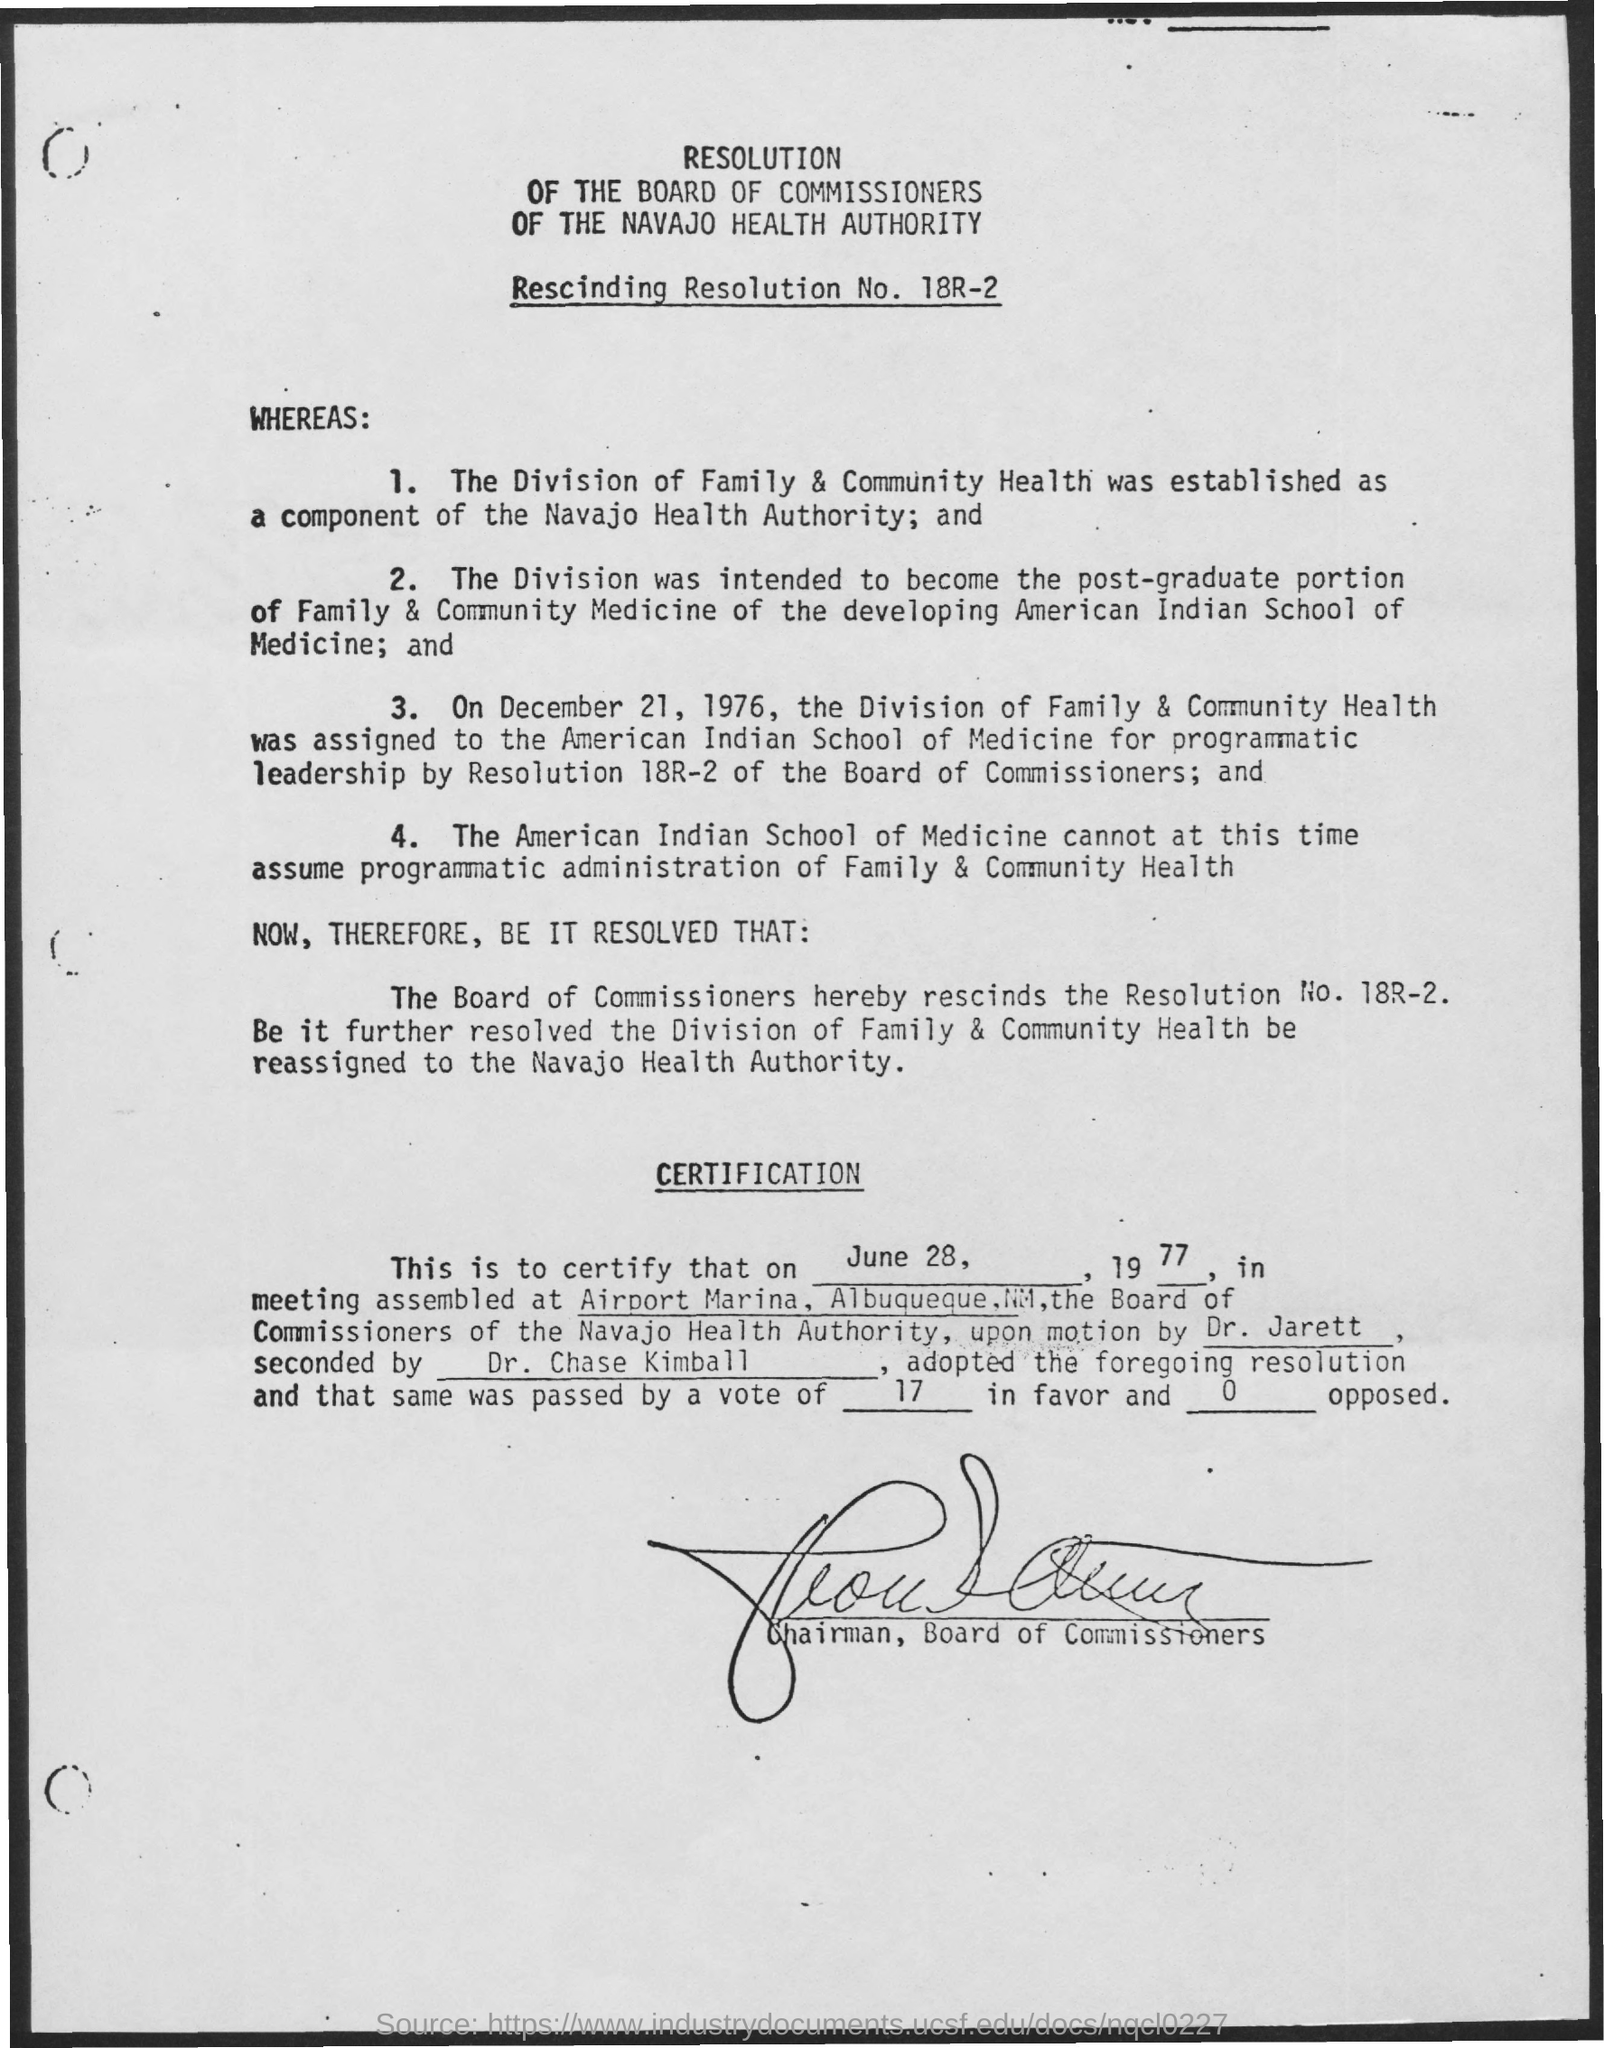Outline some significant characteristics in this image. The Navajo Health Authority established the division of Family & Community Health as a component of its organization. 